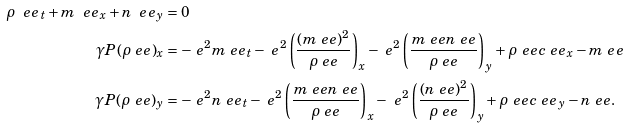Convert formula to latex. <formula><loc_0><loc_0><loc_500><loc_500>\rho \ e e _ { t } + m \ e e _ { x } + n \ e e _ { y } & = 0 \\ \gamma P ( \rho \ e e ) _ { x } & = - \ e ^ { 2 } m \ e e _ { t } - \ e ^ { 2 } \left ( \frac { ( m \ e e ) ^ { 2 } } { \rho \ e e } \right ) _ { x } - \ e ^ { 2 } \left ( \frac { m \ e e n \ e e } { \rho \ e e } \right ) _ { y } + \rho \ e e c \ e e _ { x } - m \ e e \\ \gamma P ( \rho \ e e ) _ { y } & = - \ e ^ { 2 } n \ e e _ { t } - \ e ^ { 2 } \left ( \frac { m \ e e n \ e e } { \rho \ e e } \right ) _ { x } - \ e ^ { 2 } \left ( \frac { ( n \ e e ) ^ { 2 } } { \rho \ e e } \right ) _ { y } + \rho \ e e c \ e e _ { y } - n \ e e .</formula> 